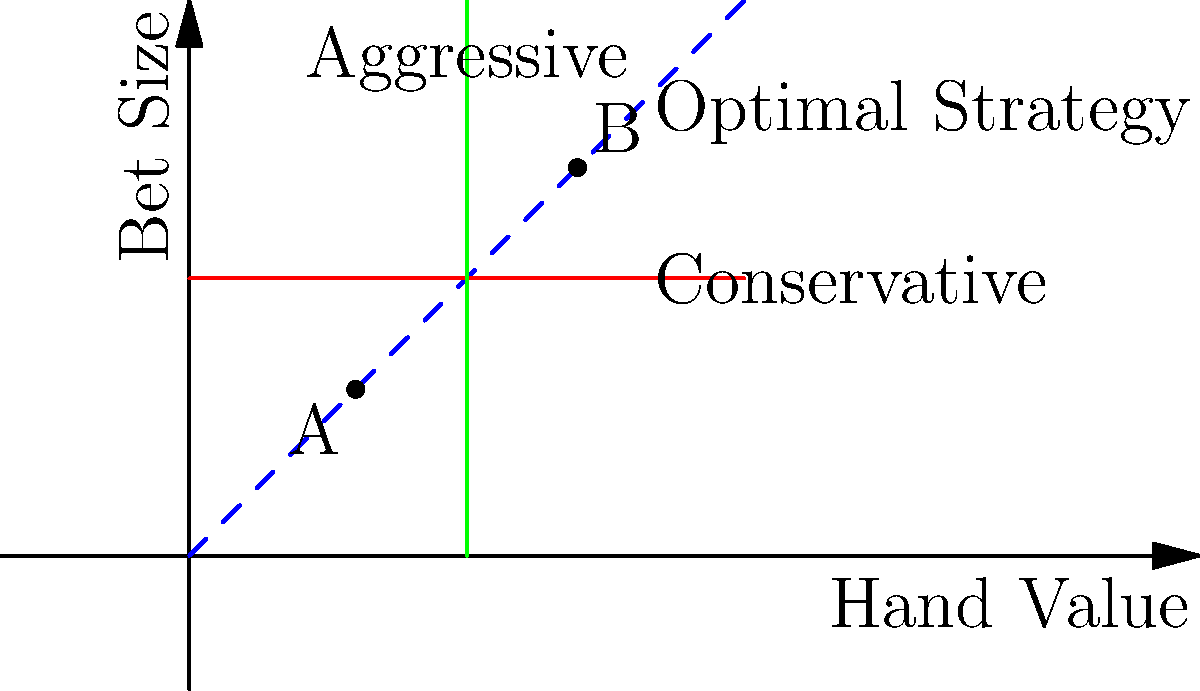In a high-stakes poker game, you've developed a coordinate system to map hand values (x-axis) against bet sizes (y-axis). The blue dashed line represents the optimal betting strategy. Point A (3,3) represents a weak hand with a small bet, while point B (7,7) represents a strong hand with a large bet. If the expected value (EV) of a bet is calculated as $EV = (x-5)(y-5)$, where x is the hand value and y is the bet size, what is the difference in EV between points A and B? Let's approach this step-by-step:

1) The formula for Expected Value (EV) is given as:
   $EV = (x-5)(y-5)$

2) For point A (3,3):
   $EV_A = (3-5)(3-5) = (-2)(-2) = 4$

3) For point B (7,7):
   $EV_B = (7-5)(7-5) = (2)(2) = 4$

4) The difference in EV is:
   $EV_B - EV_A = 4 - 4 = 0$

Therefore, despite the different positions on the optimal strategy line, both points A and B have the same Expected Value. This illustrates that the optimal strategy (represented by the blue dashed line) maintains a constant EV across different hand strengths and bet sizes.
Answer: 0 